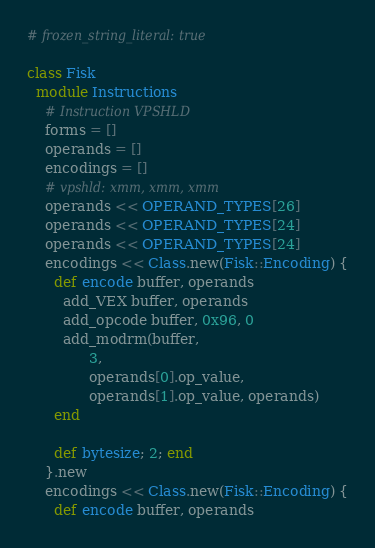<code> <loc_0><loc_0><loc_500><loc_500><_Ruby_># frozen_string_literal: true

class Fisk
  module Instructions
    # Instruction VPSHLD
    forms = []
    operands = []
    encodings = []
    # vpshld: xmm, xmm, xmm
    operands << OPERAND_TYPES[26]
    operands << OPERAND_TYPES[24]
    operands << OPERAND_TYPES[24]
    encodings << Class.new(Fisk::Encoding) {
      def encode buffer, operands
        add_VEX buffer, operands
        add_opcode buffer, 0x96, 0
        add_modrm(buffer,
              3,
              operands[0].op_value,
              operands[1].op_value, operands)
      end

      def bytesize; 2; end
    }.new
    encodings << Class.new(Fisk::Encoding) {
      def encode buffer, operands</code> 